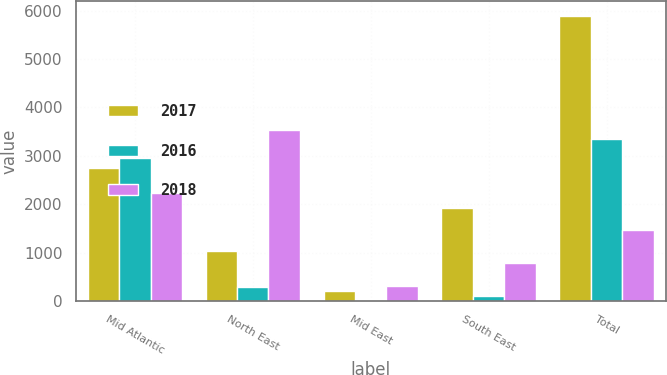<chart> <loc_0><loc_0><loc_500><loc_500><stacked_bar_chart><ecel><fcel>Mid Atlantic<fcel>North East<fcel>Mid East<fcel>South East<fcel>Total<nl><fcel>2017<fcel>2743<fcel>1033<fcel>211<fcel>1911<fcel>5898<nl><fcel>2016<fcel>2945<fcel>290<fcel>11<fcel>99<fcel>3345<nl><fcel>2018<fcel>2240<fcel>3530<fcel>303<fcel>791<fcel>1472<nl></chart> 